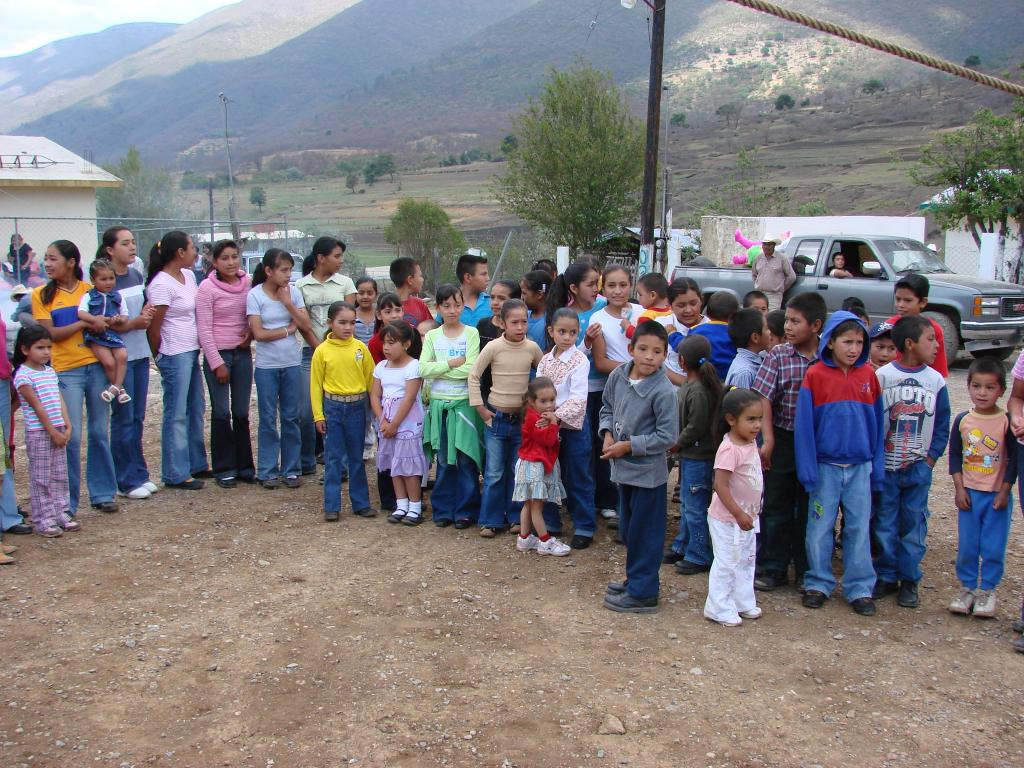What are the people in the image doing? There is a group of people standing in a row in the image. What type of structures can be seen in the image? There are buildings visible in the image. What type of vehicles are present in the image? Cars are present in the image. What type of natural elements can be seen in the image? Trees and mountains are visible in the image. What type of object can be seen in the image that is used for support or signage? There is a pole in the image. What type of object can be seen at the top of the image that is used for suspension or attachment? A rope is visible at the top of the image. Where is the bee located in the image? There is no bee present in the image. What type of container is being used to carry the pin in the image? There is no pin or container present in the image. 